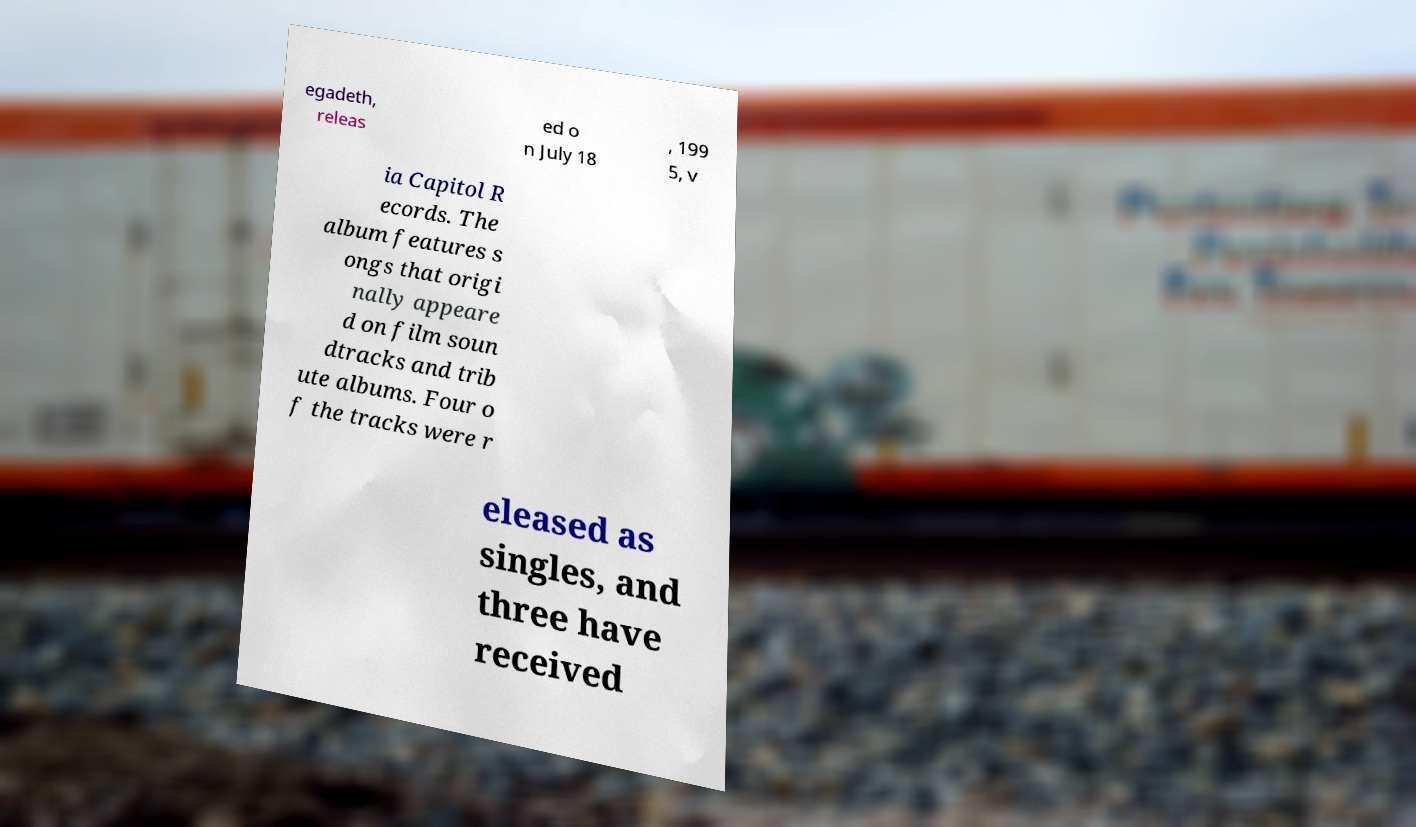There's text embedded in this image that I need extracted. Can you transcribe it verbatim? egadeth, releas ed o n July 18 , 199 5, v ia Capitol R ecords. The album features s ongs that origi nally appeare d on film soun dtracks and trib ute albums. Four o f the tracks were r eleased as singles, and three have received 